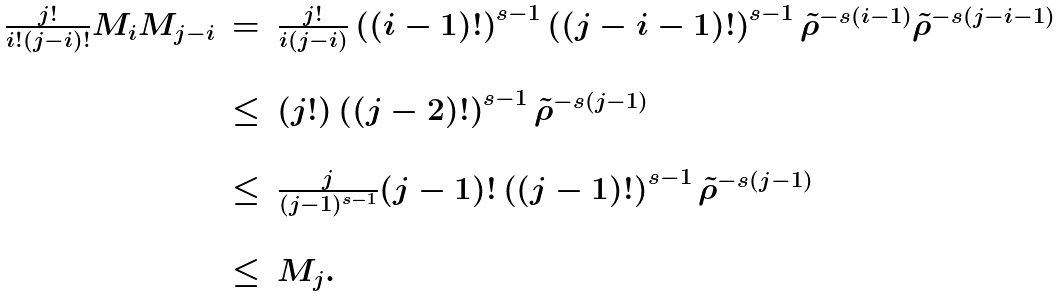<formula> <loc_0><loc_0><loc_500><loc_500>\begin{array} { l l l } \frac { j ! } { i ! ( j - i ) ! } M _ { i } M _ { j - i } & = & \frac { j ! } { i ( j - i ) } \left ( ( i - 1 ) ! \right ) ^ { s - 1 } \left ( ( j - i - 1 ) ! \right ) ^ { s - 1 } \tilde { \rho } ^ { - s ( i - 1 ) } \tilde { \rho } ^ { - s ( j - i - 1 ) } \\ \\ & \leq & ( j ! ) \left ( ( j - 2 ) ! \right ) ^ { s - 1 } \tilde { \rho } ^ { - s ( j - 1 ) } \\ \\ & \leq & \frac { j } { ( j - 1 ) ^ { s - 1 } } ( j - 1 ) ! \left ( ( j - 1 ) ! \right ) ^ { s - 1 } \tilde { \rho } ^ { - s ( j - 1 ) } \\ \\ & \leq & M _ { j } . \end{array}</formula> 